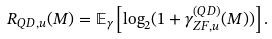Convert formula to latex. <formula><loc_0><loc_0><loc_500><loc_500>R _ { Q D , u } ( M ) = \mathbb { E } _ { \gamma } \left [ \log _ { 2 } ( 1 + \gamma _ { Z F , u } ^ { ( Q D ) } ( M ) ) \right ] .</formula> 